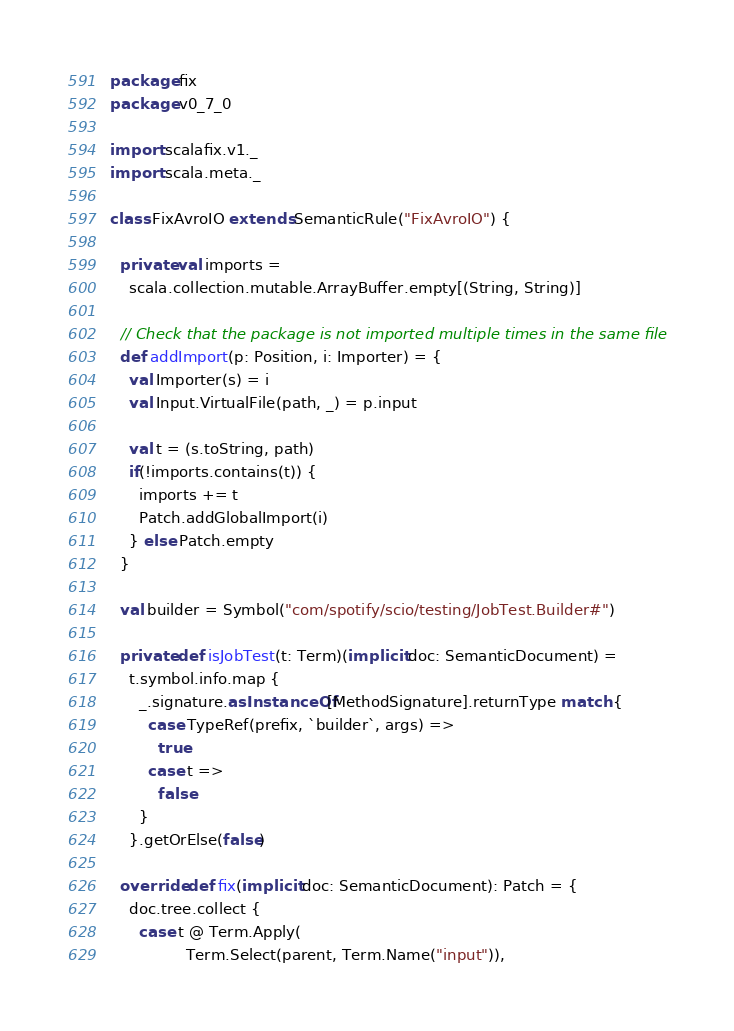<code> <loc_0><loc_0><loc_500><loc_500><_Scala_>package fix
package v0_7_0

import scalafix.v1._
import scala.meta._

class FixAvroIO extends SemanticRule("FixAvroIO") {

  private val imports =
    scala.collection.mutable.ArrayBuffer.empty[(String, String)]

  // Check that the package is not imported multiple times in the same file
  def addImport(p: Position, i: Importer) = {
    val Importer(s) = i
    val Input.VirtualFile(path, _) = p.input

    val t = (s.toString, path)
    if(!imports.contains(t)) {
      imports += t
      Patch.addGlobalImport(i)
    } else Patch.empty
  }

  val builder = Symbol("com/spotify/scio/testing/JobTest.Builder#")

  private def isJobTest(t: Term)(implicit doc: SemanticDocument) =
    t.symbol.info.map {
      _.signature.asInstanceOf[MethodSignature].returnType match {
        case TypeRef(prefix, `builder`, args) =>
          true
        case t =>
          false
      }
    }.getOrElse(false)

  override def fix(implicit doc: SemanticDocument): Patch = {
    doc.tree.collect {
      case t @ Term.Apply(
                Term.Select(parent, Term.Name("input")),</code> 